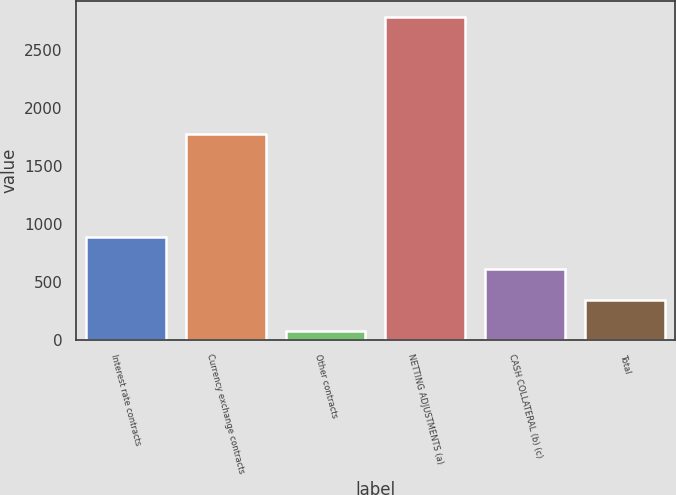Convert chart. <chart><loc_0><loc_0><loc_500><loc_500><bar_chart><fcel>Interest rate contracts<fcel>Currency exchange contracts<fcel>Other contracts<fcel>NETTING ADJUSTMENTS (a)<fcel>CASH COLLATERAL (b) (c)<fcel>Total<nl><fcel>886.2<fcel>1777<fcel>72<fcel>2786<fcel>614.8<fcel>343.4<nl></chart> 